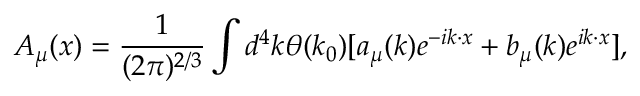<formula> <loc_0><loc_0><loc_500><loc_500>A _ { \mu } ( x ) = \frac { 1 } { ( 2 \pi ) ^ { 2 / 3 } } \int d ^ { 4 } k \theta ( k _ { 0 } ) { [ a _ { \mu } ( k ) e ^ { - i k \cdot x } + b _ { \mu } ( k ) e ^ { i k \cdot x } ] } ,</formula> 